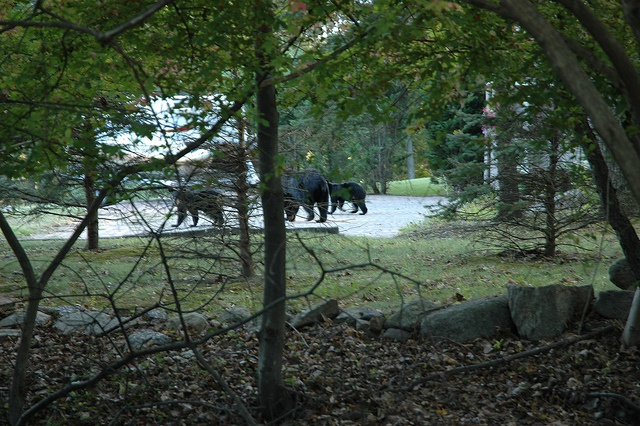Describe the objects in this image and their specific colors. I can see bear in darkgreen, black, purple, blue, and darkblue tones, bear in darkgreen, black, gray, and purple tones, and bear in darkgreen, black, darkblue, and gray tones in this image. 